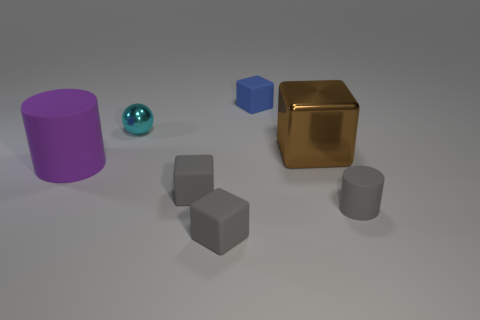Subtract all blue blocks. How many blocks are left? 3 Subtract all tiny blue matte blocks. How many blocks are left? 3 Add 2 cyan metallic cubes. How many objects exist? 9 Subtract all yellow cubes. Subtract all red spheres. How many cubes are left? 4 Subtract all cylinders. How many objects are left? 5 Add 3 brown metallic things. How many brown metallic things exist? 4 Subtract 0 red cubes. How many objects are left? 7 Subtract all tiny purple metal objects. Subtract all cyan balls. How many objects are left? 6 Add 5 tiny gray matte cylinders. How many tiny gray matte cylinders are left? 6 